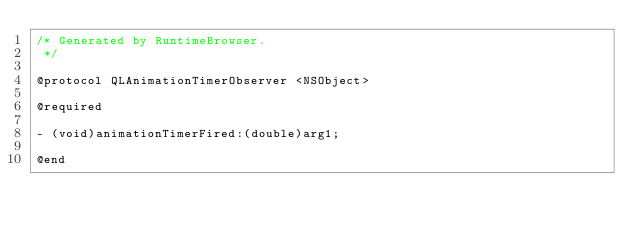Convert code to text. <code><loc_0><loc_0><loc_500><loc_500><_C_>/* Generated by RuntimeBrowser.
 */

@protocol QLAnimationTimerObserver <NSObject>

@required

- (void)animationTimerFired:(double)arg1;

@end
</code> 